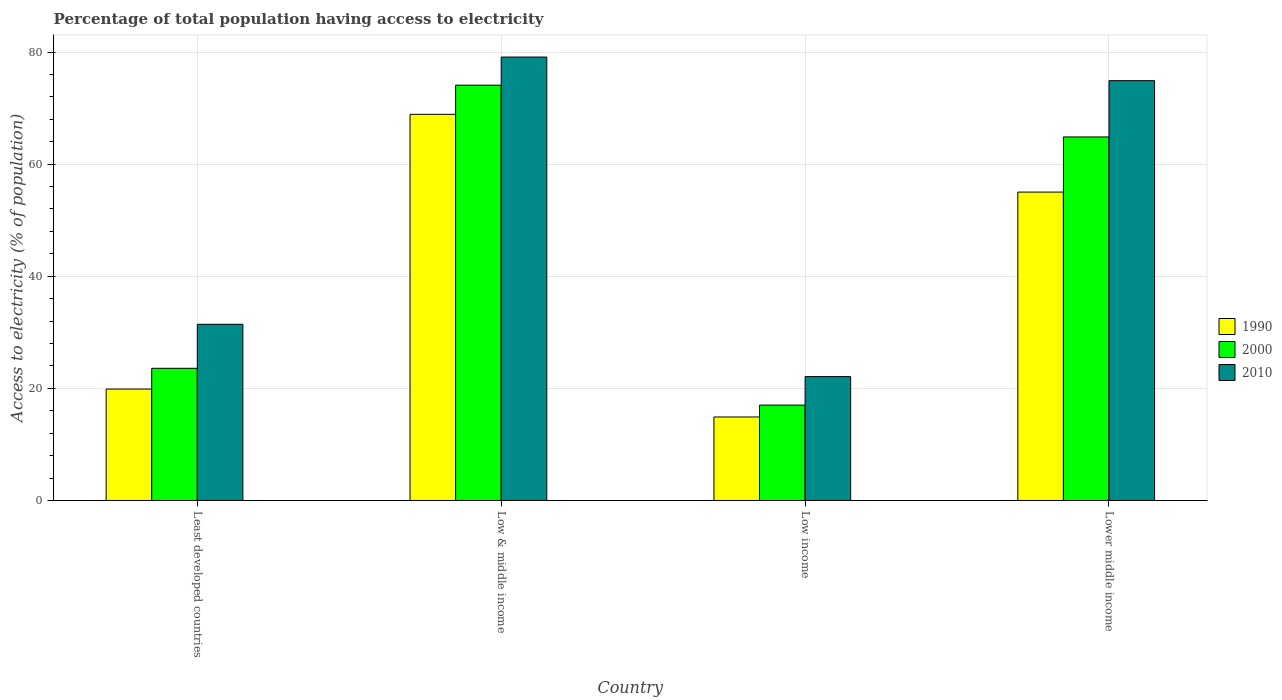How many different coloured bars are there?
Offer a very short reply. 3. How many groups of bars are there?
Keep it short and to the point. 4. How many bars are there on the 2nd tick from the left?
Your response must be concise. 3. In how many cases, is the number of bars for a given country not equal to the number of legend labels?
Provide a succinct answer. 0. What is the percentage of population that have access to electricity in 1990 in Low & middle income?
Your answer should be very brief. 68.89. Across all countries, what is the maximum percentage of population that have access to electricity in 2010?
Offer a very short reply. 79.11. Across all countries, what is the minimum percentage of population that have access to electricity in 1990?
Your response must be concise. 14.9. What is the total percentage of population that have access to electricity in 1990 in the graph?
Your answer should be very brief. 158.68. What is the difference between the percentage of population that have access to electricity in 2000 in Least developed countries and that in Lower middle income?
Give a very brief answer. -41.27. What is the difference between the percentage of population that have access to electricity in 1990 in Low & middle income and the percentage of population that have access to electricity in 2000 in Lower middle income?
Make the answer very short. 4.03. What is the average percentage of population that have access to electricity in 2000 per country?
Your answer should be very brief. 44.88. What is the difference between the percentage of population that have access to electricity of/in 2010 and percentage of population that have access to electricity of/in 2000 in Lower middle income?
Your answer should be very brief. 10.04. In how many countries, is the percentage of population that have access to electricity in 1990 greater than 48 %?
Make the answer very short. 2. What is the ratio of the percentage of population that have access to electricity in 2000 in Least developed countries to that in Low & middle income?
Provide a succinct answer. 0.32. Is the difference between the percentage of population that have access to electricity in 2010 in Least developed countries and Lower middle income greater than the difference between the percentage of population that have access to electricity in 2000 in Least developed countries and Lower middle income?
Provide a short and direct response. No. What is the difference between the highest and the second highest percentage of population that have access to electricity in 1990?
Ensure brevity in your answer.  -49.01. What is the difference between the highest and the lowest percentage of population that have access to electricity in 1990?
Make the answer very short. 53.99. Is it the case that in every country, the sum of the percentage of population that have access to electricity in 1990 and percentage of population that have access to electricity in 2000 is greater than the percentage of population that have access to electricity in 2010?
Give a very brief answer. Yes. How many bars are there?
Your answer should be very brief. 12. What is the difference between two consecutive major ticks on the Y-axis?
Offer a terse response. 20. Are the values on the major ticks of Y-axis written in scientific E-notation?
Your answer should be compact. No. Does the graph contain grids?
Offer a very short reply. Yes. Where does the legend appear in the graph?
Your answer should be very brief. Center right. How many legend labels are there?
Keep it short and to the point. 3. What is the title of the graph?
Your answer should be compact. Percentage of total population having access to electricity. What is the label or title of the Y-axis?
Your answer should be compact. Access to electricity (% of population). What is the Access to electricity (% of population) of 1990 in Least developed countries?
Your response must be concise. 19.88. What is the Access to electricity (% of population) of 2000 in Least developed countries?
Provide a short and direct response. 23.58. What is the Access to electricity (% of population) of 2010 in Least developed countries?
Ensure brevity in your answer.  31.44. What is the Access to electricity (% of population) in 1990 in Low & middle income?
Provide a succinct answer. 68.89. What is the Access to electricity (% of population) of 2000 in Low & middle income?
Ensure brevity in your answer.  74.09. What is the Access to electricity (% of population) in 2010 in Low & middle income?
Make the answer very short. 79.11. What is the Access to electricity (% of population) in 1990 in Low income?
Provide a succinct answer. 14.9. What is the Access to electricity (% of population) of 2000 in Low income?
Offer a terse response. 17.01. What is the Access to electricity (% of population) in 2010 in Low income?
Make the answer very short. 22.1. What is the Access to electricity (% of population) of 1990 in Lower middle income?
Your answer should be very brief. 55.02. What is the Access to electricity (% of population) in 2000 in Lower middle income?
Offer a terse response. 64.85. What is the Access to electricity (% of population) of 2010 in Lower middle income?
Your answer should be very brief. 74.89. Across all countries, what is the maximum Access to electricity (% of population) of 1990?
Offer a very short reply. 68.89. Across all countries, what is the maximum Access to electricity (% of population) of 2000?
Make the answer very short. 74.09. Across all countries, what is the maximum Access to electricity (% of population) in 2010?
Provide a short and direct response. 79.11. Across all countries, what is the minimum Access to electricity (% of population) in 1990?
Keep it short and to the point. 14.9. Across all countries, what is the minimum Access to electricity (% of population) in 2000?
Your response must be concise. 17.01. Across all countries, what is the minimum Access to electricity (% of population) in 2010?
Offer a very short reply. 22.1. What is the total Access to electricity (% of population) in 1990 in the graph?
Offer a terse response. 158.68. What is the total Access to electricity (% of population) of 2000 in the graph?
Your answer should be compact. 179.54. What is the total Access to electricity (% of population) of 2010 in the graph?
Your answer should be compact. 207.53. What is the difference between the Access to electricity (% of population) of 1990 in Least developed countries and that in Low & middle income?
Offer a very short reply. -49.01. What is the difference between the Access to electricity (% of population) of 2000 in Least developed countries and that in Low & middle income?
Your answer should be very brief. -50.51. What is the difference between the Access to electricity (% of population) of 2010 in Least developed countries and that in Low & middle income?
Offer a terse response. -47.67. What is the difference between the Access to electricity (% of population) of 1990 in Least developed countries and that in Low income?
Give a very brief answer. 4.98. What is the difference between the Access to electricity (% of population) in 2000 in Least developed countries and that in Low income?
Offer a terse response. 6.56. What is the difference between the Access to electricity (% of population) of 2010 in Least developed countries and that in Low income?
Provide a short and direct response. 9.33. What is the difference between the Access to electricity (% of population) of 1990 in Least developed countries and that in Lower middle income?
Offer a terse response. -35.14. What is the difference between the Access to electricity (% of population) in 2000 in Least developed countries and that in Lower middle income?
Offer a terse response. -41.27. What is the difference between the Access to electricity (% of population) of 2010 in Least developed countries and that in Lower middle income?
Your response must be concise. -43.46. What is the difference between the Access to electricity (% of population) in 1990 in Low & middle income and that in Low income?
Provide a succinct answer. 53.99. What is the difference between the Access to electricity (% of population) of 2000 in Low & middle income and that in Low income?
Offer a very short reply. 57.07. What is the difference between the Access to electricity (% of population) of 2010 in Low & middle income and that in Low income?
Your response must be concise. 57. What is the difference between the Access to electricity (% of population) in 1990 in Low & middle income and that in Lower middle income?
Ensure brevity in your answer.  13.87. What is the difference between the Access to electricity (% of population) of 2000 in Low & middle income and that in Lower middle income?
Your response must be concise. 9.24. What is the difference between the Access to electricity (% of population) of 2010 in Low & middle income and that in Lower middle income?
Offer a terse response. 4.21. What is the difference between the Access to electricity (% of population) of 1990 in Low income and that in Lower middle income?
Your answer should be compact. -40.12. What is the difference between the Access to electricity (% of population) in 2000 in Low income and that in Lower middle income?
Keep it short and to the point. -47.84. What is the difference between the Access to electricity (% of population) of 2010 in Low income and that in Lower middle income?
Provide a short and direct response. -52.79. What is the difference between the Access to electricity (% of population) of 1990 in Least developed countries and the Access to electricity (% of population) of 2000 in Low & middle income?
Give a very brief answer. -54.21. What is the difference between the Access to electricity (% of population) of 1990 in Least developed countries and the Access to electricity (% of population) of 2010 in Low & middle income?
Your response must be concise. -59.23. What is the difference between the Access to electricity (% of population) in 2000 in Least developed countries and the Access to electricity (% of population) in 2010 in Low & middle income?
Offer a very short reply. -55.53. What is the difference between the Access to electricity (% of population) in 1990 in Least developed countries and the Access to electricity (% of population) in 2000 in Low income?
Give a very brief answer. 2.86. What is the difference between the Access to electricity (% of population) of 1990 in Least developed countries and the Access to electricity (% of population) of 2010 in Low income?
Ensure brevity in your answer.  -2.22. What is the difference between the Access to electricity (% of population) of 2000 in Least developed countries and the Access to electricity (% of population) of 2010 in Low income?
Provide a succinct answer. 1.48. What is the difference between the Access to electricity (% of population) of 1990 in Least developed countries and the Access to electricity (% of population) of 2000 in Lower middle income?
Offer a very short reply. -44.97. What is the difference between the Access to electricity (% of population) in 1990 in Least developed countries and the Access to electricity (% of population) in 2010 in Lower middle income?
Provide a short and direct response. -55.01. What is the difference between the Access to electricity (% of population) of 2000 in Least developed countries and the Access to electricity (% of population) of 2010 in Lower middle income?
Provide a short and direct response. -51.31. What is the difference between the Access to electricity (% of population) in 1990 in Low & middle income and the Access to electricity (% of population) in 2000 in Low income?
Provide a short and direct response. 51.87. What is the difference between the Access to electricity (% of population) in 1990 in Low & middle income and the Access to electricity (% of population) in 2010 in Low income?
Your answer should be very brief. 46.79. What is the difference between the Access to electricity (% of population) of 2000 in Low & middle income and the Access to electricity (% of population) of 2010 in Low income?
Provide a short and direct response. 51.99. What is the difference between the Access to electricity (% of population) in 1990 in Low & middle income and the Access to electricity (% of population) in 2000 in Lower middle income?
Your answer should be very brief. 4.03. What is the difference between the Access to electricity (% of population) of 1990 in Low & middle income and the Access to electricity (% of population) of 2010 in Lower middle income?
Give a very brief answer. -6.01. What is the difference between the Access to electricity (% of population) of 2000 in Low & middle income and the Access to electricity (% of population) of 2010 in Lower middle income?
Your answer should be very brief. -0.8. What is the difference between the Access to electricity (% of population) in 1990 in Low income and the Access to electricity (% of population) in 2000 in Lower middle income?
Make the answer very short. -49.96. What is the difference between the Access to electricity (% of population) of 1990 in Low income and the Access to electricity (% of population) of 2010 in Lower middle income?
Offer a very short reply. -60. What is the difference between the Access to electricity (% of population) of 2000 in Low income and the Access to electricity (% of population) of 2010 in Lower middle income?
Ensure brevity in your answer.  -57.88. What is the average Access to electricity (% of population) of 1990 per country?
Offer a terse response. 39.67. What is the average Access to electricity (% of population) of 2000 per country?
Provide a succinct answer. 44.88. What is the average Access to electricity (% of population) in 2010 per country?
Offer a very short reply. 51.88. What is the difference between the Access to electricity (% of population) in 1990 and Access to electricity (% of population) in 2000 in Least developed countries?
Make the answer very short. -3.7. What is the difference between the Access to electricity (% of population) of 1990 and Access to electricity (% of population) of 2010 in Least developed countries?
Give a very brief answer. -11.56. What is the difference between the Access to electricity (% of population) of 2000 and Access to electricity (% of population) of 2010 in Least developed countries?
Provide a short and direct response. -7.86. What is the difference between the Access to electricity (% of population) of 1990 and Access to electricity (% of population) of 2000 in Low & middle income?
Provide a succinct answer. -5.2. What is the difference between the Access to electricity (% of population) in 1990 and Access to electricity (% of population) in 2010 in Low & middle income?
Keep it short and to the point. -10.22. What is the difference between the Access to electricity (% of population) of 2000 and Access to electricity (% of population) of 2010 in Low & middle income?
Your answer should be compact. -5.02. What is the difference between the Access to electricity (% of population) of 1990 and Access to electricity (% of population) of 2000 in Low income?
Offer a terse response. -2.12. What is the difference between the Access to electricity (% of population) of 1990 and Access to electricity (% of population) of 2010 in Low income?
Your answer should be compact. -7.2. What is the difference between the Access to electricity (% of population) of 2000 and Access to electricity (% of population) of 2010 in Low income?
Ensure brevity in your answer.  -5.09. What is the difference between the Access to electricity (% of population) in 1990 and Access to electricity (% of population) in 2000 in Lower middle income?
Give a very brief answer. -9.84. What is the difference between the Access to electricity (% of population) of 1990 and Access to electricity (% of population) of 2010 in Lower middle income?
Keep it short and to the point. -19.87. What is the difference between the Access to electricity (% of population) of 2000 and Access to electricity (% of population) of 2010 in Lower middle income?
Provide a succinct answer. -10.04. What is the ratio of the Access to electricity (% of population) in 1990 in Least developed countries to that in Low & middle income?
Offer a terse response. 0.29. What is the ratio of the Access to electricity (% of population) in 2000 in Least developed countries to that in Low & middle income?
Provide a succinct answer. 0.32. What is the ratio of the Access to electricity (% of population) of 2010 in Least developed countries to that in Low & middle income?
Ensure brevity in your answer.  0.4. What is the ratio of the Access to electricity (% of population) of 1990 in Least developed countries to that in Low income?
Your answer should be compact. 1.33. What is the ratio of the Access to electricity (% of population) of 2000 in Least developed countries to that in Low income?
Offer a very short reply. 1.39. What is the ratio of the Access to electricity (% of population) in 2010 in Least developed countries to that in Low income?
Your answer should be very brief. 1.42. What is the ratio of the Access to electricity (% of population) in 1990 in Least developed countries to that in Lower middle income?
Ensure brevity in your answer.  0.36. What is the ratio of the Access to electricity (% of population) of 2000 in Least developed countries to that in Lower middle income?
Your response must be concise. 0.36. What is the ratio of the Access to electricity (% of population) of 2010 in Least developed countries to that in Lower middle income?
Provide a succinct answer. 0.42. What is the ratio of the Access to electricity (% of population) of 1990 in Low & middle income to that in Low income?
Ensure brevity in your answer.  4.62. What is the ratio of the Access to electricity (% of population) of 2000 in Low & middle income to that in Low income?
Offer a terse response. 4.35. What is the ratio of the Access to electricity (% of population) in 2010 in Low & middle income to that in Low income?
Give a very brief answer. 3.58. What is the ratio of the Access to electricity (% of population) of 1990 in Low & middle income to that in Lower middle income?
Your answer should be very brief. 1.25. What is the ratio of the Access to electricity (% of population) in 2000 in Low & middle income to that in Lower middle income?
Provide a succinct answer. 1.14. What is the ratio of the Access to electricity (% of population) of 2010 in Low & middle income to that in Lower middle income?
Your answer should be very brief. 1.06. What is the ratio of the Access to electricity (% of population) in 1990 in Low income to that in Lower middle income?
Provide a succinct answer. 0.27. What is the ratio of the Access to electricity (% of population) in 2000 in Low income to that in Lower middle income?
Make the answer very short. 0.26. What is the ratio of the Access to electricity (% of population) of 2010 in Low income to that in Lower middle income?
Give a very brief answer. 0.3. What is the difference between the highest and the second highest Access to electricity (% of population) in 1990?
Give a very brief answer. 13.87. What is the difference between the highest and the second highest Access to electricity (% of population) in 2000?
Offer a very short reply. 9.24. What is the difference between the highest and the second highest Access to electricity (% of population) of 2010?
Keep it short and to the point. 4.21. What is the difference between the highest and the lowest Access to electricity (% of population) of 1990?
Your answer should be compact. 53.99. What is the difference between the highest and the lowest Access to electricity (% of population) in 2000?
Provide a succinct answer. 57.07. What is the difference between the highest and the lowest Access to electricity (% of population) of 2010?
Keep it short and to the point. 57. 